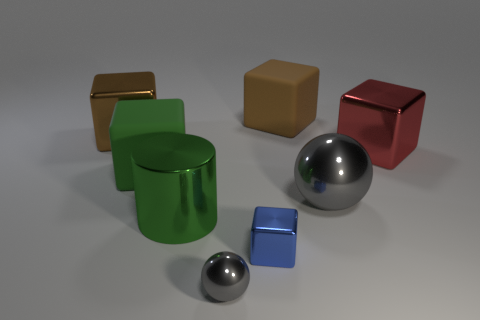There is a blue thing to the right of the big brown cube to the left of the green metallic object; what is it made of?
Keep it short and to the point. Metal. What is the size of the green thing that is behind the big ball?
Your answer should be compact. Large. There is a small ball; is its color the same as the matte cube behind the large brown metallic cube?
Give a very brief answer. No. Is there a big metallic object that has the same color as the big metallic sphere?
Your answer should be compact. No. Is the material of the green cylinder the same as the brown block that is to the right of the large green rubber cube?
Offer a terse response. No. How many large things are gray shiny spheres or brown matte blocks?
Provide a short and direct response. 2. There is a big ball that is the same color as the small sphere; what is its material?
Your response must be concise. Metal. Is the number of tiny blue metallic objects less than the number of tiny purple rubber objects?
Your response must be concise. No. There is a rubber block that is on the left side of the tiny shiny ball; is it the same size as the brown rubber thing to the right of the tiny blue cube?
Your answer should be very brief. Yes. What number of blue objects are either big balls or tiny shiny objects?
Your answer should be compact. 1. 